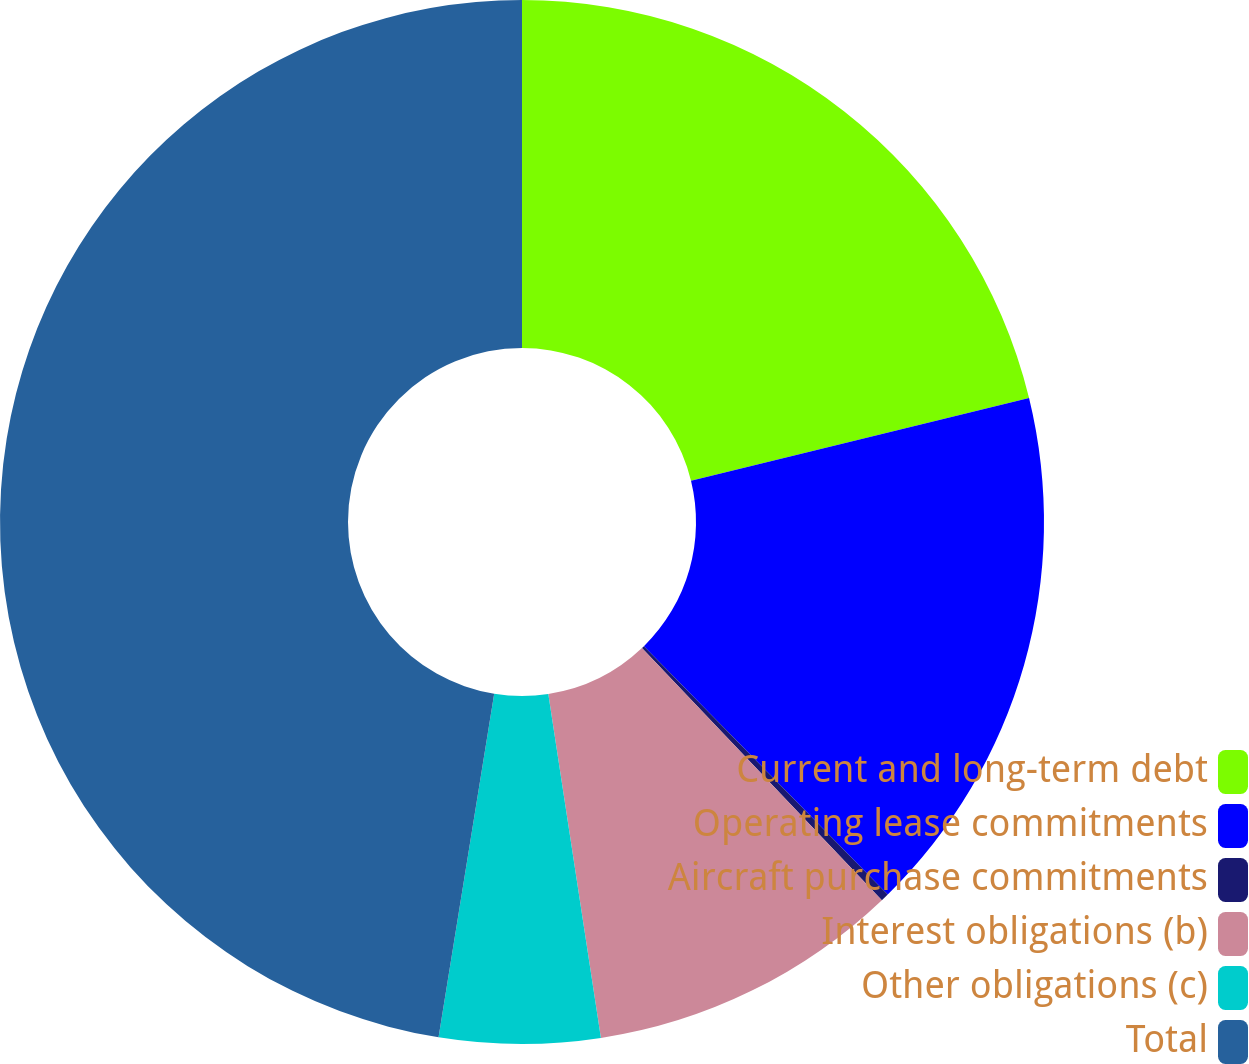Convert chart to OTSL. <chart><loc_0><loc_0><loc_500><loc_500><pie_chart><fcel>Current and long-term debt<fcel>Operating lease commitments<fcel>Aircraft purchase commitments<fcel>Interest obligations (b)<fcel>Other obligations (c)<fcel>Total<nl><fcel>21.18%<fcel>16.46%<fcel>0.25%<fcel>9.69%<fcel>4.97%<fcel>47.44%<nl></chart> 